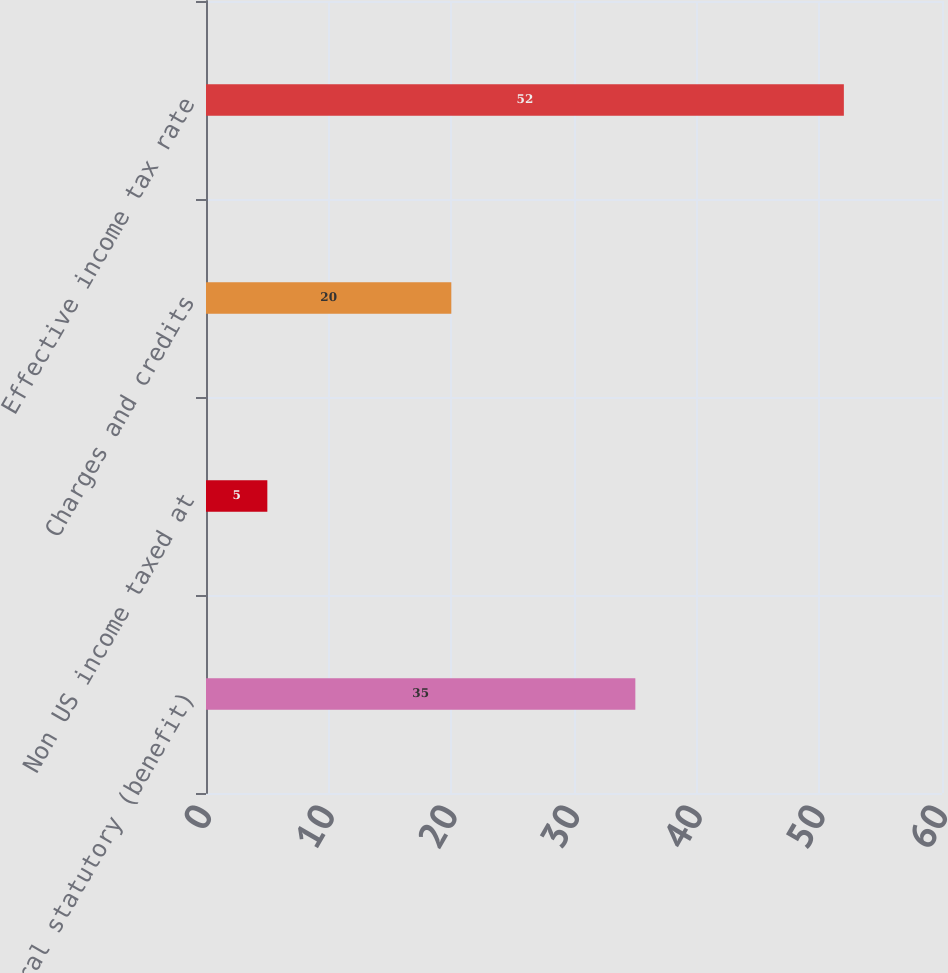Convert chart. <chart><loc_0><loc_0><loc_500><loc_500><bar_chart><fcel>US federal statutory (benefit)<fcel>Non US income taxed at<fcel>Charges and credits<fcel>Effective income tax rate<nl><fcel>35<fcel>5<fcel>20<fcel>52<nl></chart> 